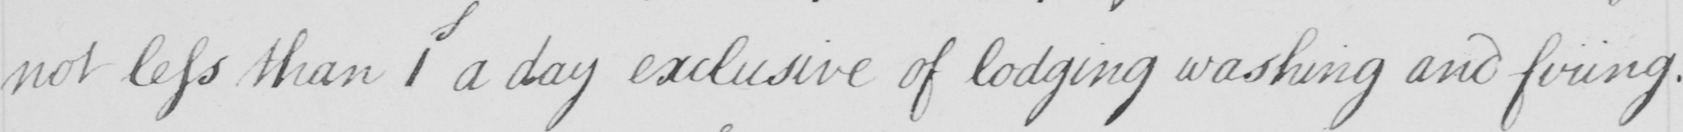Can you tell me what this handwritten text says? not less than 1 a day exclusive of lodging washing and firing : 